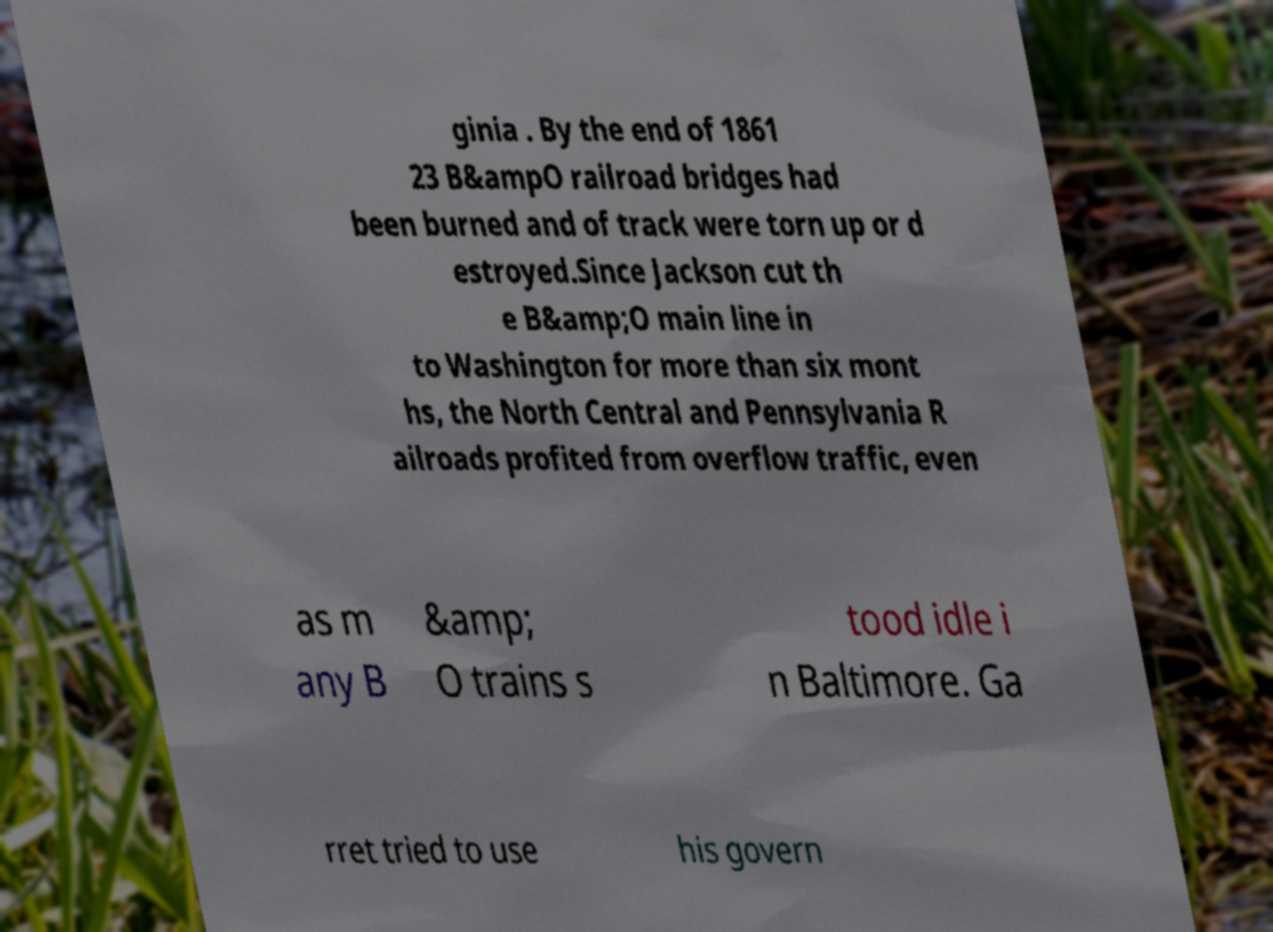Please read and relay the text visible in this image. What does it say? ginia . By the end of 1861 23 B&ampO railroad bridges had been burned and of track were torn up or d estroyed.Since Jackson cut th e B&amp;O main line in to Washington for more than six mont hs, the North Central and Pennsylvania R ailroads profited from overflow traffic, even as m any B &amp; O trains s tood idle i n Baltimore. Ga rret tried to use his govern 